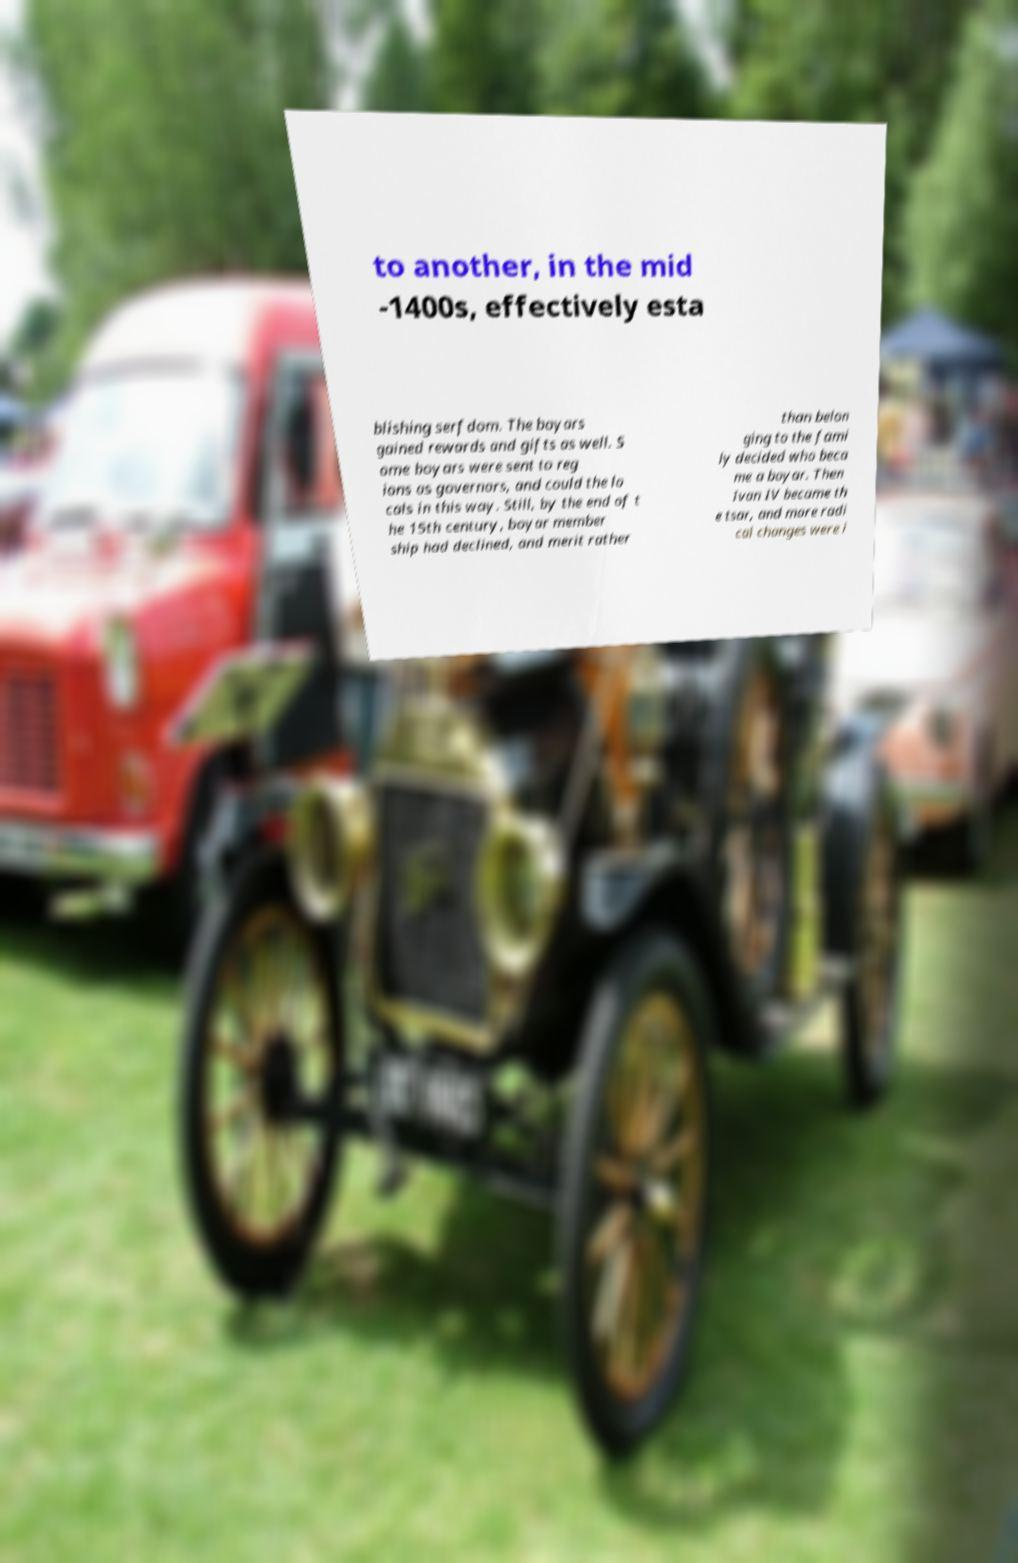For documentation purposes, I need the text within this image transcribed. Could you provide that? to another, in the mid -1400s, effectively esta blishing serfdom. The boyars gained rewards and gifts as well. S ome boyars were sent to reg ions as governors, and could the lo cals in this way. Still, by the end of t he 15th century, boyar member ship had declined, and merit rather than belon ging to the fami ly decided who beca me a boyar. Then Ivan IV became th e tsar, and more radi cal changes were i 